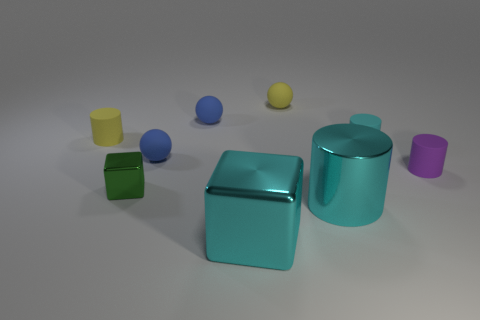Add 1 large purple blocks. How many objects exist? 10 Subtract 1 spheres. How many spheres are left? 2 Subtract all large metallic cylinders. How many cylinders are left? 3 Subtract all blocks. How many objects are left? 7 Subtract all small red objects. Subtract all yellow cylinders. How many objects are left? 8 Add 5 small metal blocks. How many small metal blocks are left? 6 Add 5 shiny cylinders. How many shiny cylinders exist? 6 Subtract all cyan cubes. How many cubes are left? 1 Subtract 0 cyan balls. How many objects are left? 9 Subtract all red cylinders. Subtract all red blocks. How many cylinders are left? 4 